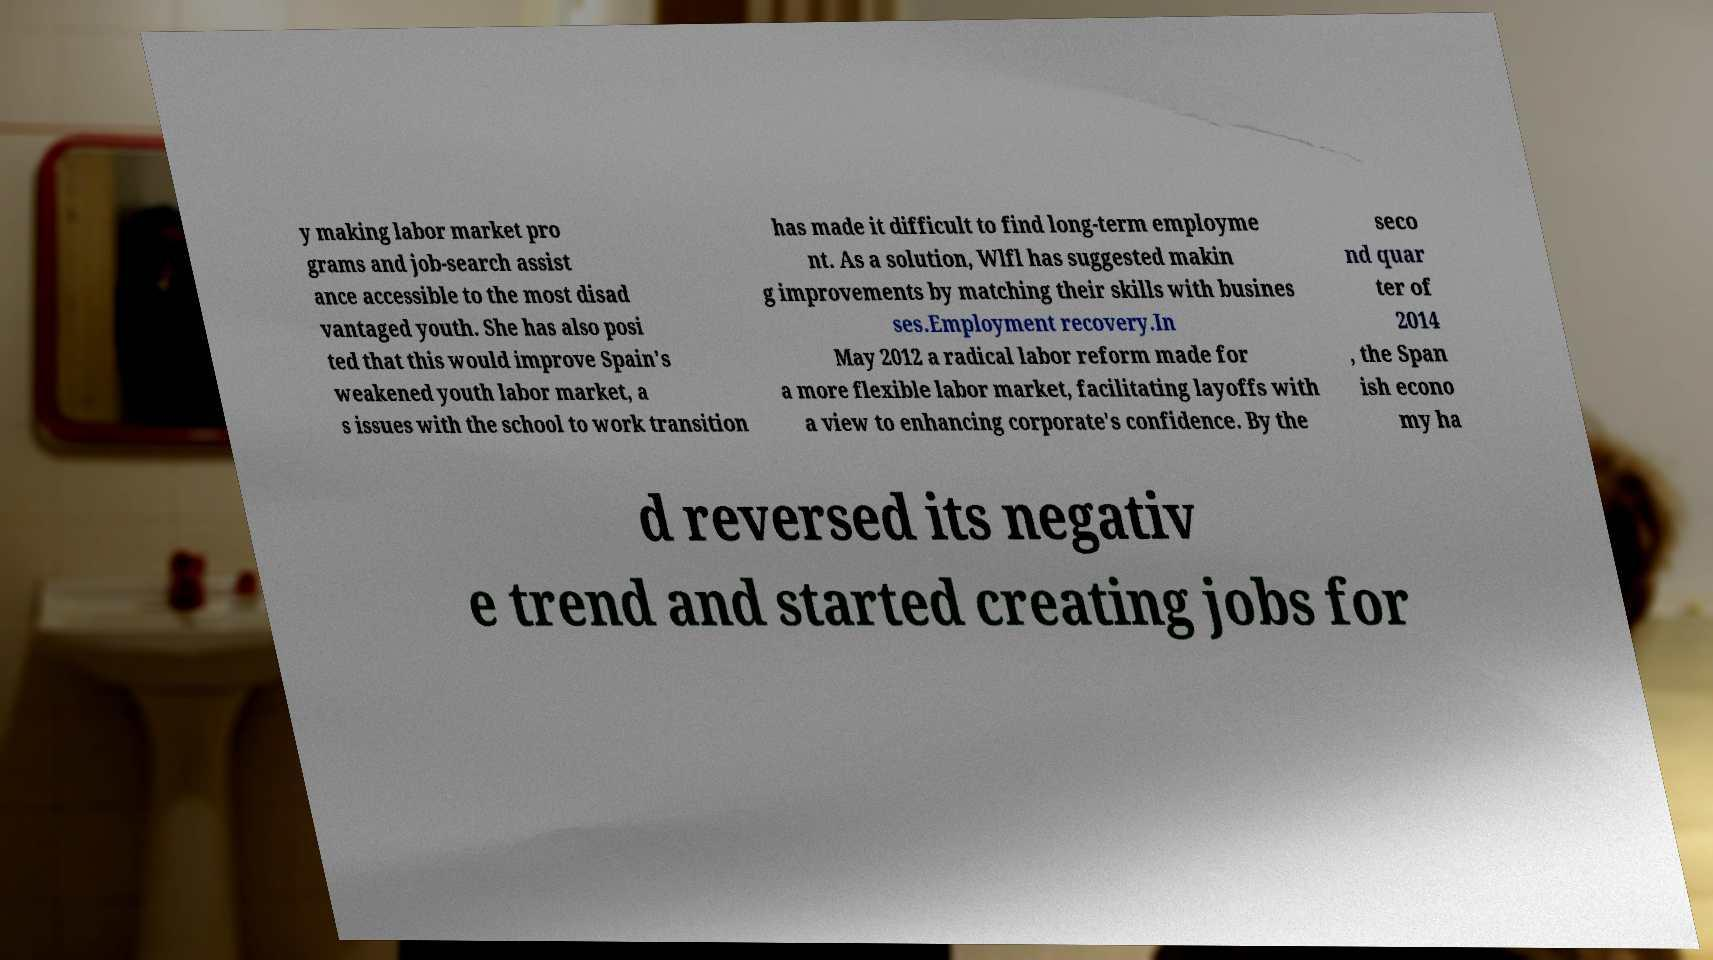Can you read and provide the text displayed in the image?This photo seems to have some interesting text. Can you extract and type it out for me? y making labor market pro grams and job-search assist ance accessible to the most disad vantaged youth. She has also posi ted that this would improve Spain's weakened youth labor market, a s issues with the school to work transition has made it difficult to find long-term employme nt. As a solution, Wlfl has suggested makin g improvements by matching their skills with busines ses.Employment recovery.In May 2012 a radical labor reform made for a more flexible labor market, facilitating layoffs with a view to enhancing corporate's confidence. By the seco nd quar ter of 2014 , the Span ish econo my ha d reversed its negativ e trend and started creating jobs for 